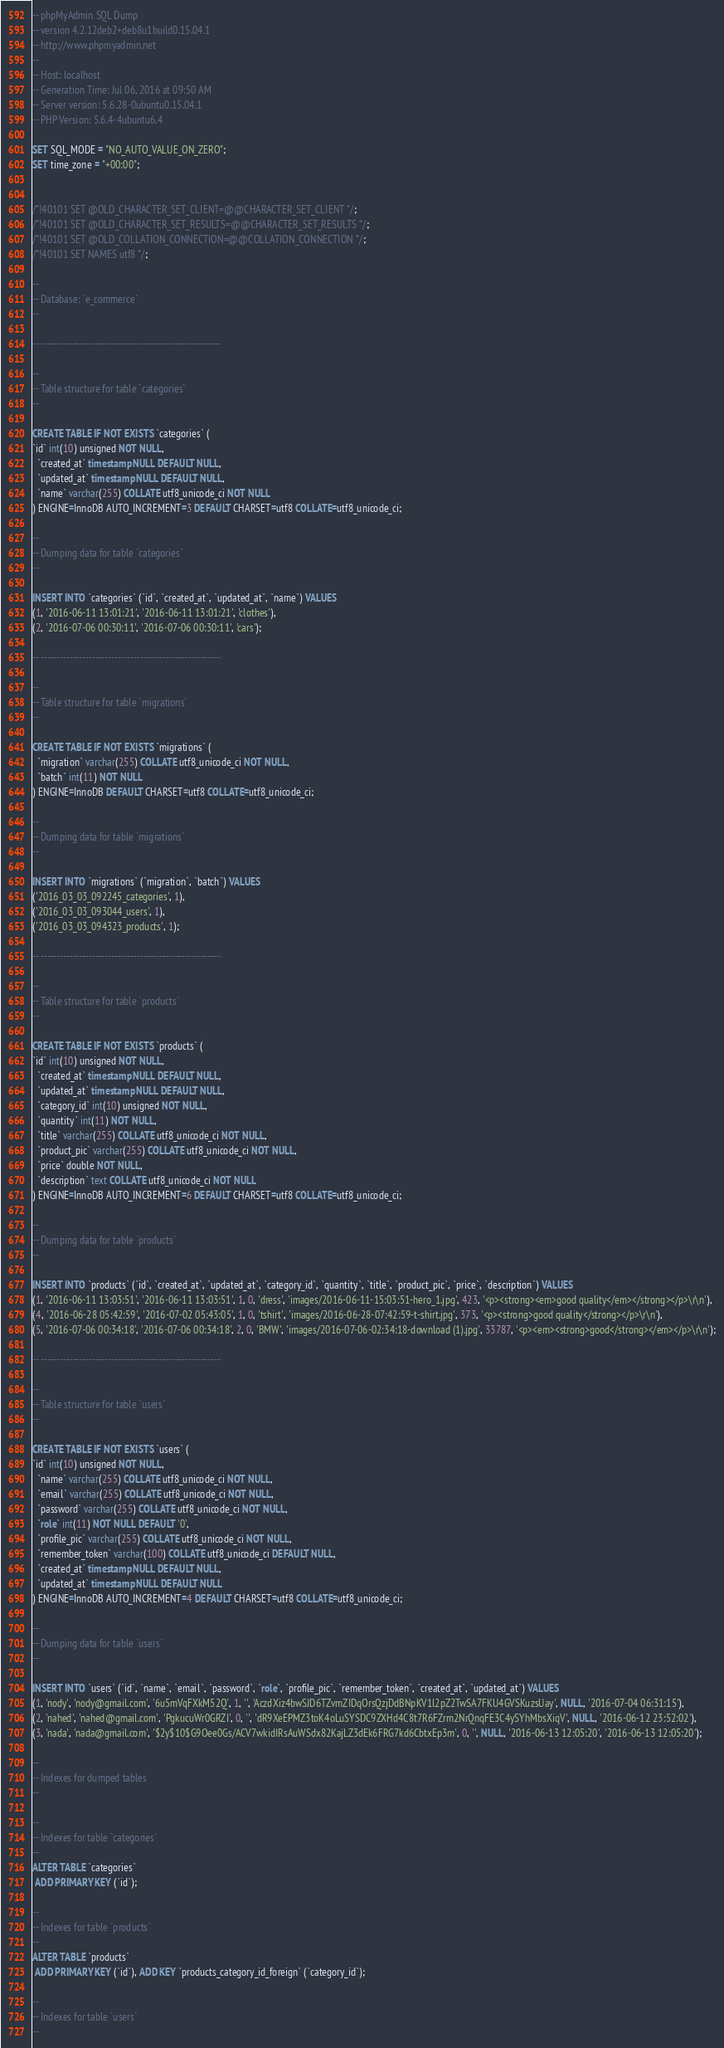Convert code to text. <code><loc_0><loc_0><loc_500><loc_500><_SQL_>-- phpMyAdmin SQL Dump
-- version 4.2.12deb2+deb8u1build0.15.04.1
-- http://www.phpmyadmin.net
--
-- Host: localhost
-- Generation Time: Jul 06, 2016 at 09:50 AM
-- Server version: 5.6.28-0ubuntu0.15.04.1
-- PHP Version: 5.6.4-4ubuntu6.4

SET SQL_MODE = "NO_AUTO_VALUE_ON_ZERO";
SET time_zone = "+00:00";


/*!40101 SET @OLD_CHARACTER_SET_CLIENT=@@CHARACTER_SET_CLIENT */;
/*!40101 SET @OLD_CHARACTER_SET_RESULTS=@@CHARACTER_SET_RESULTS */;
/*!40101 SET @OLD_COLLATION_CONNECTION=@@COLLATION_CONNECTION */;
/*!40101 SET NAMES utf8 */;

--
-- Database: `e_commerce`
--

-- --------------------------------------------------------

--
-- Table structure for table `categories`
--

CREATE TABLE IF NOT EXISTS `categories` (
`id` int(10) unsigned NOT NULL,
  `created_at` timestamp NULL DEFAULT NULL,
  `updated_at` timestamp NULL DEFAULT NULL,
  `name` varchar(255) COLLATE utf8_unicode_ci NOT NULL
) ENGINE=InnoDB AUTO_INCREMENT=3 DEFAULT CHARSET=utf8 COLLATE=utf8_unicode_ci;

--
-- Dumping data for table `categories`
--

INSERT INTO `categories` (`id`, `created_at`, `updated_at`, `name`) VALUES
(1, '2016-06-11 13:01:21', '2016-06-11 13:01:21', 'clothes'),
(2, '2016-07-06 00:30:11', '2016-07-06 00:30:11', 'cars');

-- --------------------------------------------------------

--
-- Table structure for table `migrations`
--

CREATE TABLE IF NOT EXISTS `migrations` (
  `migration` varchar(255) COLLATE utf8_unicode_ci NOT NULL,
  `batch` int(11) NOT NULL
) ENGINE=InnoDB DEFAULT CHARSET=utf8 COLLATE=utf8_unicode_ci;

--
-- Dumping data for table `migrations`
--

INSERT INTO `migrations` (`migration`, `batch`) VALUES
('2016_03_03_092245_categories', 1),
('2016_03_03_093044_users', 1),
('2016_03_03_094323_products', 1);

-- --------------------------------------------------------

--
-- Table structure for table `products`
--

CREATE TABLE IF NOT EXISTS `products` (
`id` int(10) unsigned NOT NULL,
  `created_at` timestamp NULL DEFAULT NULL,
  `updated_at` timestamp NULL DEFAULT NULL,
  `category_id` int(10) unsigned NOT NULL,
  `quantity` int(11) NOT NULL,
  `title` varchar(255) COLLATE utf8_unicode_ci NOT NULL,
  `product_pic` varchar(255) COLLATE utf8_unicode_ci NOT NULL,
  `price` double NOT NULL,
  `description` text COLLATE utf8_unicode_ci NOT NULL
) ENGINE=InnoDB AUTO_INCREMENT=6 DEFAULT CHARSET=utf8 COLLATE=utf8_unicode_ci;

--
-- Dumping data for table `products`
--

INSERT INTO `products` (`id`, `created_at`, `updated_at`, `category_id`, `quantity`, `title`, `product_pic`, `price`, `description`) VALUES
(1, '2016-06-11 13:03:51', '2016-06-11 13:03:51', 1, 0, 'dress', 'images/2016-06-11-15:03:51-hero_1.jpg', 423, '<p><strong><em>good quality</em></strong></p>\r\n'),
(4, '2016-06-28 05:42:59', '2016-07-02 05:43:05', 1, 0, 'tshirt', 'images/2016-06-28-07:42:59-t-shirt.jpg', 373, '<p><strong>good quality</strong></p>\r\n'),
(5, '2016-07-06 00:34:18', '2016-07-06 00:34:18', 2, 0, 'BMW', 'images/2016-07-06-02:34:18-download (1).jpg', 33787, '<p><em><strong>good</strong></em></p>\r\n');

-- --------------------------------------------------------

--
-- Table structure for table `users`
--

CREATE TABLE IF NOT EXISTS `users` (
`id` int(10) unsigned NOT NULL,
  `name` varchar(255) COLLATE utf8_unicode_ci NOT NULL,
  `email` varchar(255) COLLATE utf8_unicode_ci NOT NULL,
  `password` varchar(255) COLLATE utf8_unicode_ci NOT NULL,
  `role` int(11) NOT NULL DEFAULT '0',
  `profile_pic` varchar(255) COLLATE utf8_unicode_ci NOT NULL,
  `remember_token` varchar(100) COLLATE utf8_unicode_ci DEFAULT NULL,
  `created_at` timestamp NULL DEFAULT NULL,
  `updated_at` timestamp NULL DEFAULT NULL
) ENGINE=InnoDB AUTO_INCREMENT=4 DEFAULT CHARSET=utf8 COLLATE=utf8_unicode_ci;

--
-- Dumping data for table `users`
--

INSERT INTO `users` (`id`, `name`, `email`, `password`, `role`, `profile_pic`, `remember_token`, `created_at`, `updated_at`) VALUES
(1, 'nody', 'nody@gmail.com', '6u5mVqFXkM52Q', 1, '', 'AczdXiz4bwSJD6TZvmZIDqOrsQzjDdBNpKV1l2pZ2TwSA7FKU4GVSKuzsUay', NULL, '2016-07-04 06:31:15'),
(2, 'nahed', 'nahed@gmail.com', 'PgkucuWr0GRZI', 0, '', 'dR9XeEPMZ3toK4oLuSYSDC9ZXHd4C8t7R6FZrm2NrQnqFE3C4ySYhMbsXiqV', NULL, '2016-06-12 23:52:02'),
(3, 'nada', 'nada@gmail.com', '$2y$10$G9Oee0Gs/ACV7wkidIRsAuWSdx82KajLZ3dEk6FRG7kd6CbtxEp3m', 0, '', NULL, '2016-06-13 12:05:20', '2016-06-13 12:05:20');

--
-- Indexes for dumped tables
--

--
-- Indexes for table `categories`
--
ALTER TABLE `categories`
 ADD PRIMARY KEY (`id`);

--
-- Indexes for table `products`
--
ALTER TABLE `products`
 ADD PRIMARY KEY (`id`), ADD KEY `products_category_id_foreign` (`category_id`);

--
-- Indexes for table `users`
--</code> 